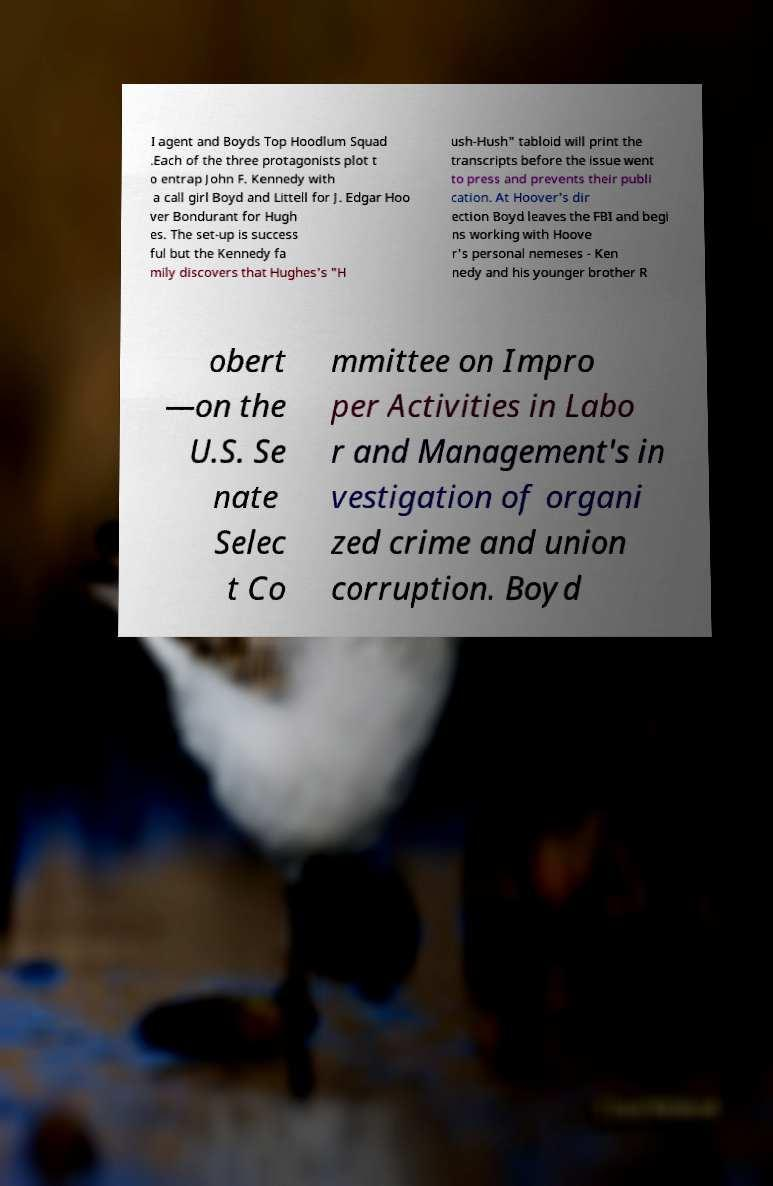Please identify and transcribe the text found in this image. I agent and Boyds Top Hoodlum Squad .Each of the three protagonists plot t o entrap John F. Kennedy with a call girl Boyd and Littell for J. Edgar Hoo ver Bondurant for Hugh es. The set-up is success ful but the Kennedy fa mily discovers that Hughes's "H ush-Hush" tabloid will print the transcripts before the issue went to press and prevents their publi cation. At Hoover's dir ection Boyd leaves the FBI and begi ns working with Hoove r's personal nemeses - Ken nedy and his younger brother R obert —on the U.S. Se nate Selec t Co mmittee on Impro per Activities in Labo r and Management's in vestigation of organi zed crime and union corruption. Boyd 